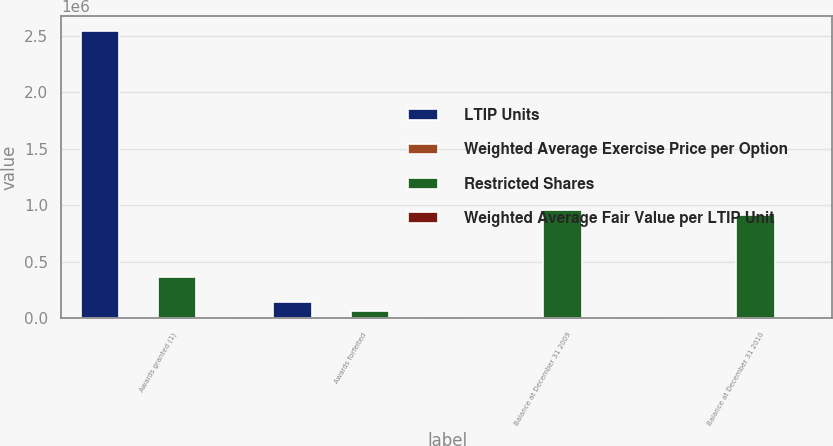<chart> <loc_0><loc_0><loc_500><loc_500><stacked_bar_chart><ecel><fcel>Awards granted (1)<fcel>Awards forfeited<fcel>Balance at December 31 2009<fcel>Balance at December 31 2010<nl><fcel>LTIP Units<fcel>2.541e+06<fcel>146151<fcel>36.19<fcel>36.19<nl><fcel>Weighted Average Exercise Price per Option<fcel>23.08<fcel>30.07<fcel>32.03<fcel>33<nl><fcel>Restricted Shares<fcel>362997<fcel>64280<fcel>954366<fcel>911950<nl><fcel>Weighted Average Fair Value per LTIP Unit<fcel>22.62<fcel>35.28<fcel>37.1<fcel>32.05<nl></chart> 